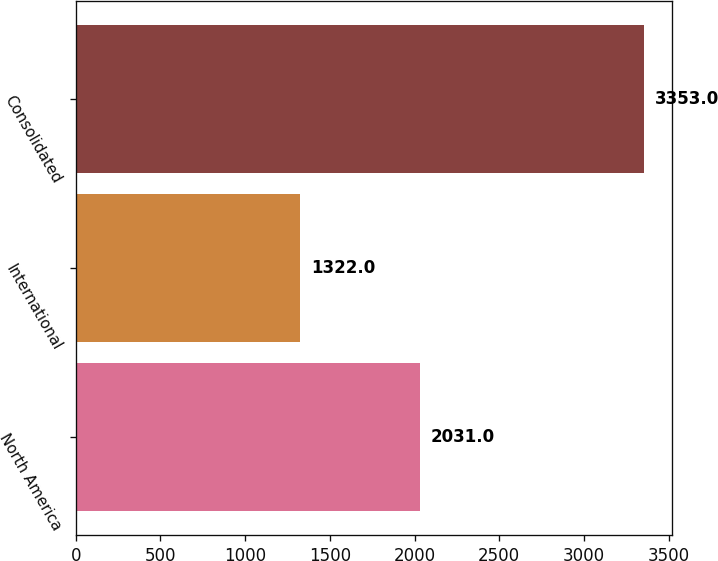Convert chart to OTSL. <chart><loc_0><loc_0><loc_500><loc_500><bar_chart><fcel>North America<fcel>International<fcel>Consolidated<nl><fcel>2031<fcel>1322<fcel>3353<nl></chart> 